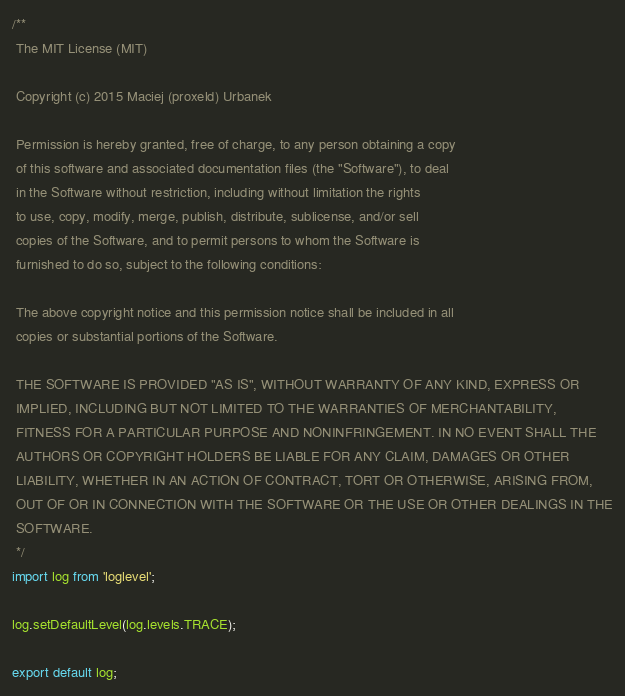Convert code to text. <code><loc_0><loc_0><loc_500><loc_500><_JavaScript_>/**
 The MIT License (MIT)

 Copyright (c) 2015 Maciej (proxeld) Urbanek

 Permission is hereby granted, free of charge, to any person obtaining a copy
 of this software and associated documentation files (the "Software"), to deal
 in the Software without restriction, including without limitation the rights
 to use, copy, modify, merge, publish, distribute, sublicense, and/or sell
 copies of the Software, and to permit persons to whom the Software is
 furnished to do so, subject to the following conditions:

 The above copyright notice and this permission notice shall be included in all
 copies or substantial portions of the Software.

 THE SOFTWARE IS PROVIDED "AS IS", WITHOUT WARRANTY OF ANY KIND, EXPRESS OR
 IMPLIED, INCLUDING BUT NOT LIMITED TO THE WARRANTIES OF MERCHANTABILITY,
 FITNESS FOR A PARTICULAR PURPOSE AND NONINFRINGEMENT. IN NO EVENT SHALL THE
 AUTHORS OR COPYRIGHT HOLDERS BE LIABLE FOR ANY CLAIM, DAMAGES OR OTHER
 LIABILITY, WHETHER IN AN ACTION OF CONTRACT, TORT OR OTHERWISE, ARISING FROM,
 OUT OF OR IN CONNECTION WITH THE SOFTWARE OR THE USE OR OTHER DEALINGS IN THE
 SOFTWARE.
 */
import log from 'loglevel';

log.setDefaultLevel(log.levels.TRACE);

export default log;
</code> 